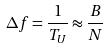<formula> <loc_0><loc_0><loc_500><loc_500>\Delta f = \frac { 1 } { T _ { U } } \approx \frac { B } { N }</formula> 